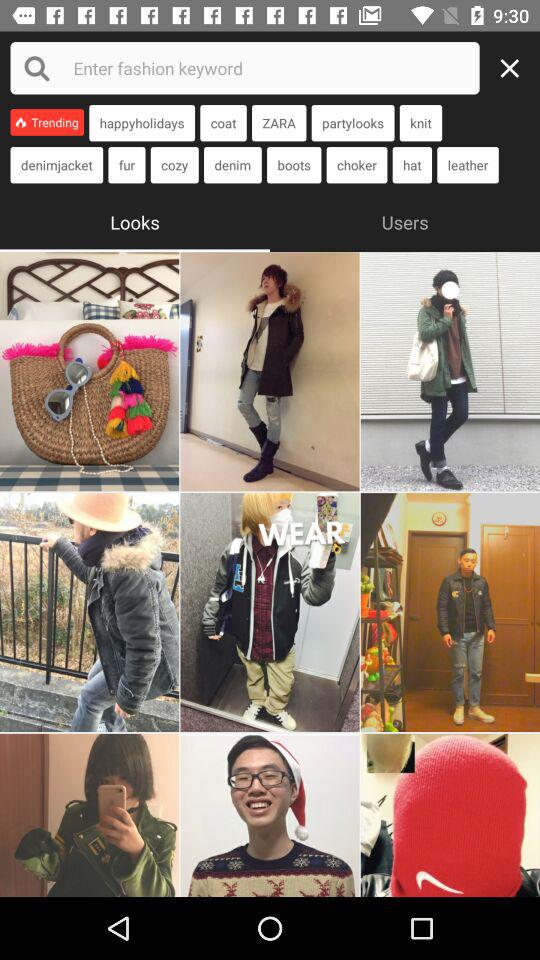What is the selected tab? The selected tab is "Looks". 